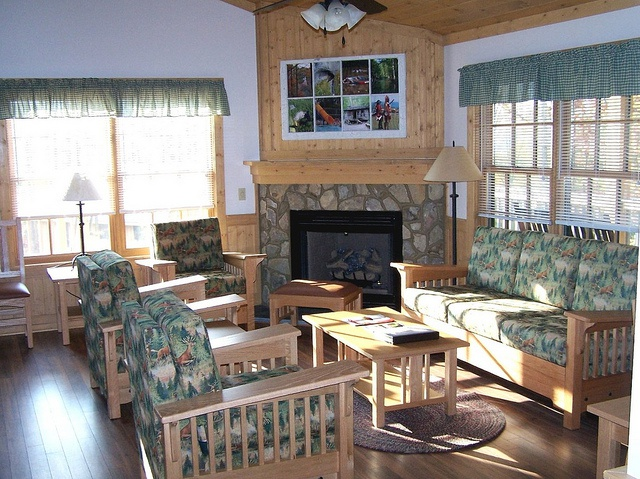Describe the objects in this image and their specific colors. I can see chair in gray and darkgray tones, couch in gray, ivory, and darkgray tones, chair in gray, black, and white tones, chair in gray and black tones, and tv in gray and black tones in this image. 